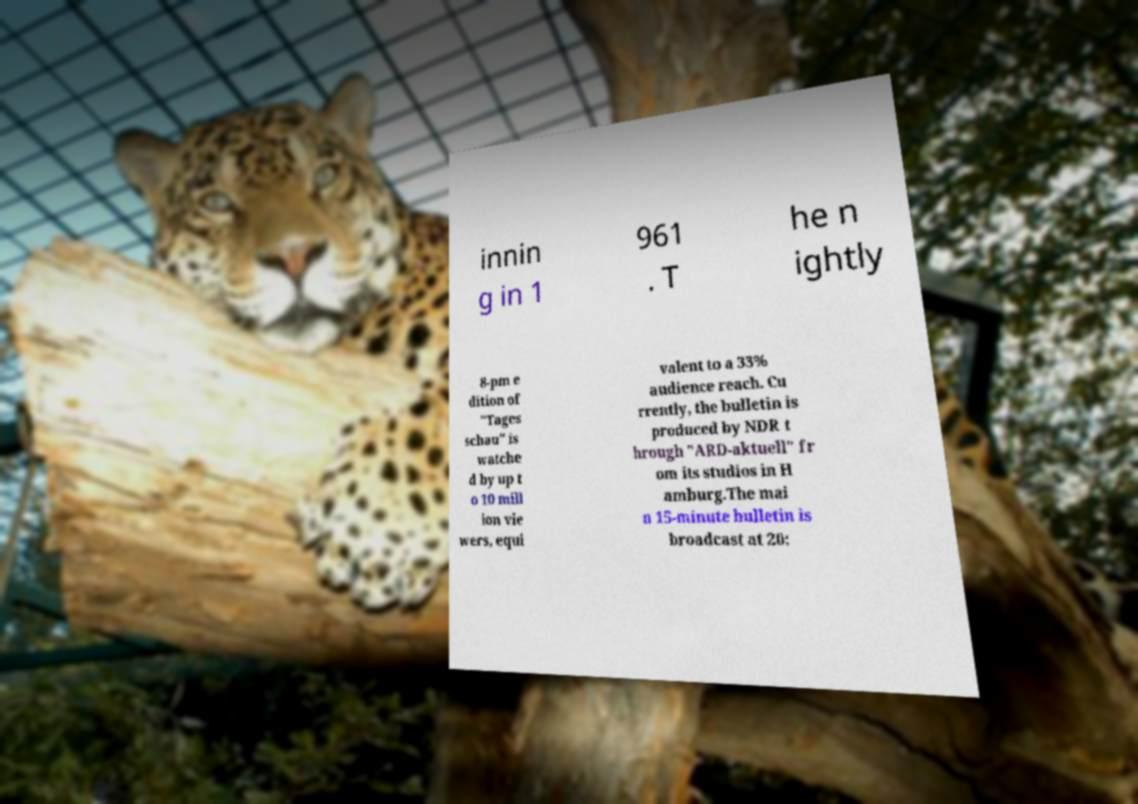I need the written content from this picture converted into text. Can you do that? innin g in 1 961 . T he n ightly 8-pm e dition of "Tages schau" is watche d by up t o 10 mill ion vie wers, equi valent to a 33% audience reach. Cu rrently, the bulletin is produced by NDR t hrough "ARD-aktuell" fr om its studios in H amburg.The mai n 15-minute bulletin is broadcast at 20: 